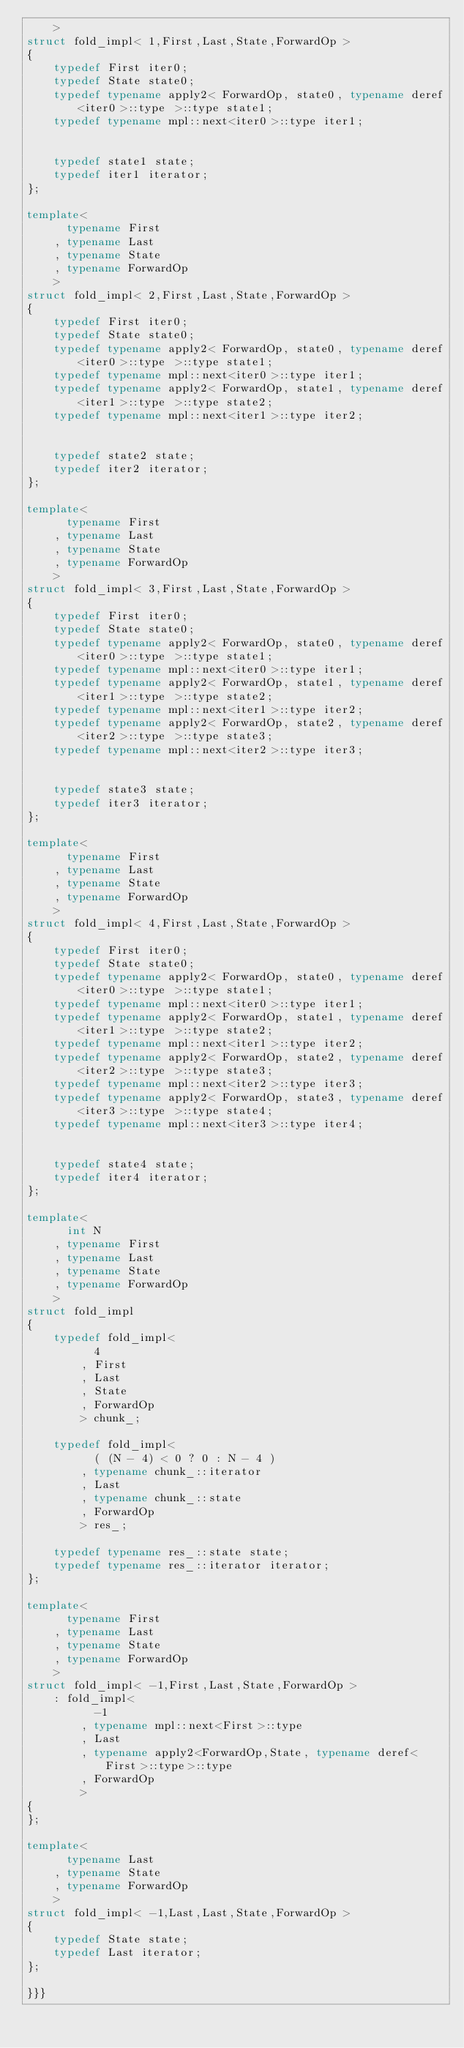<code> <loc_0><loc_0><loc_500><loc_500><_C++_>    >
struct fold_impl< 1,First,Last,State,ForwardOp >
{
    typedef First iter0;
    typedef State state0;
    typedef typename apply2< ForwardOp, state0, typename deref<iter0>::type >::type state1;
    typedef typename mpl::next<iter0>::type iter1;
    

    typedef state1 state;
    typedef iter1 iterator;
};

template<
      typename First
    , typename Last
    , typename State
    , typename ForwardOp
    >
struct fold_impl< 2,First,Last,State,ForwardOp >
{
    typedef First iter0;
    typedef State state0;
    typedef typename apply2< ForwardOp, state0, typename deref<iter0>::type >::type state1;
    typedef typename mpl::next<iter0>::type iter1;
    typedef typename apply2< ForwardOp, state1, typename deref<iter1>::type >::type state2;
    typedef typename mpl::next<iter1>::type iter2;
    

    typedef state2 state;
    typedef iter2 iterator;
};

template<
      typename First
    , typename Last
    , typename State
    , typename ForwardOp
    >
struct fold_impl< 3,First,Last,State,ForwardOp >
{
    typedef First iter0;
    typedef State state0;
    typedef typename apply2< ForwardOp, state0, typename deref<iter0>::type >::type state1;
    typedef typename mpl::next<iter0>::type iter1;
    typedef typename apply2< ForwardOp, state1, typename deref<iter1>::type >::type state2;
    typedef typename mpl::next<iter1>::type iter2;
    typedef typename apply2< ForwardOp, state2, typename deref<iter2>::type >::type state3;
    typedef typename mpl::next<iter2>::type iter3;
    

    typedef state3 state;
    typedef iter3 iterator;
};

template<
      typename First
    , typename Last
    , typename State
    , typename ForwardOp
    >
struct fold_impl< 4,First,Last,State,ForwardOp >
{
    typedef First iter0;
    typedef State state0;
    typedef typename apply2< ForwardOp, state0, typename deref<iter0>::type >::type state1;
    typedef typename mpl::next<iter0>::type iter1;
    typedef typename apply2< ForwardOp, state1, typename deref<iter1>::type >::type state2;
    typedef typename mpl::next<iter1>::type iter2;
    typedef typename apply2< ForwardOp, state2, typename deref<iter2>::type >::type state3;
    typedef typename mpl::next<iter2>::type iter3;
    typedef typename apply2< ForwardOp, state3, typename deref<iter3>::type >::type state4;
    typedef typename mpl::next<iter3>::type iter4;
    

    typedef state4 state;
    typedef iter4 iterator;
};

template<
      int N
    , typename First
    , typename Last
    , typename State
    , typename ForwardOp
    >
struct fold_impl
{
    typedef fold_impl<
          4
        , First
        , Last
        , State
        , ForwardOp
        > chunk_;

    typedef fold_impl<
          ( (N - 4) < 0 ? 0 : N - 4 )
        , typename chunk_::iterator
        , Last
        , typename chunk_::state
        , ForwardOp
        > res_;

    typedef typename res_::state state;
    typedef typename res_::iterator iterator;
};

template<
      typename First
    , typename Last
    , typename State
    , typename ForwardOp
    >
struct fold_impl< -1,First,Last,State,ForwardOp >
    : fold_impl<
          -1
        , typename mpl::next<First>::type
        , Last
        , typename apply2<ForwardOp,State, typename deref<First>::type>::type
        , ForwardOp
        >
{
};

template<
      typename Last
    , typename State
    , typename ForwardOp
    >
struct fold_impl< -1,Last,Last,State,ForwardOp >
{
    typedef State state;
    typedef Last iterator;
};

}}}
</code> 